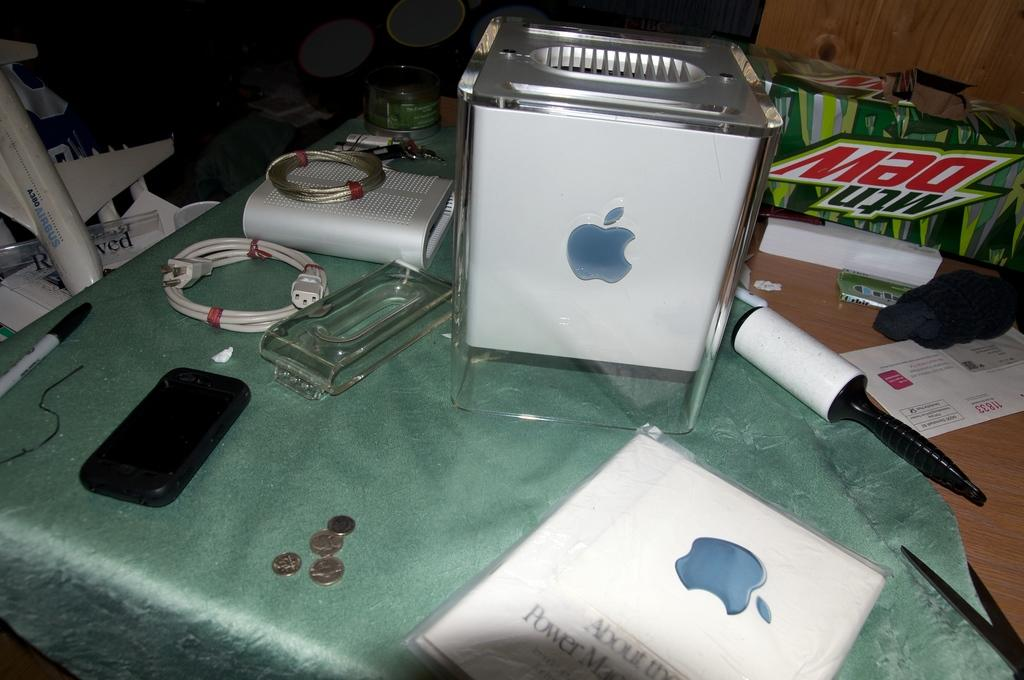<image>
Describe the image concisely. a mtn dew box behind a box with an apple logo on it 